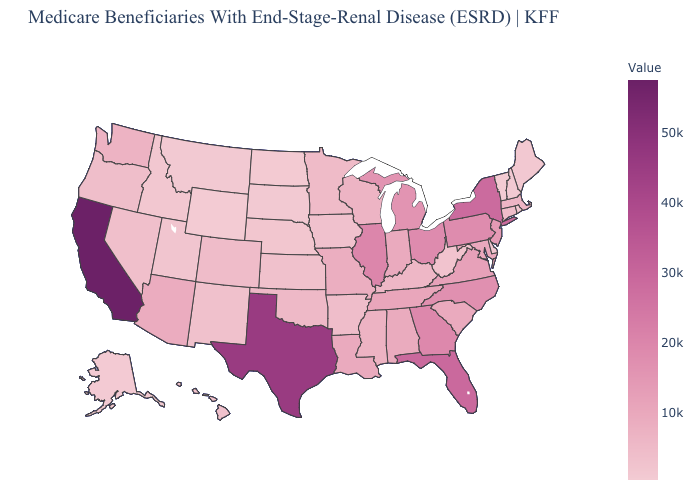Which states have the highest value in the USA?
Quick response, please. California. Does California have the highest value in the USA?
Give a very brief answer. Yes. Which states have the lowest value in the West?
Concise answer only. Wyoming. Does the map have missing data?
Give a very brief answer. No. Does California have the highest value in the USA?
Give a very brief answer. Yes. 